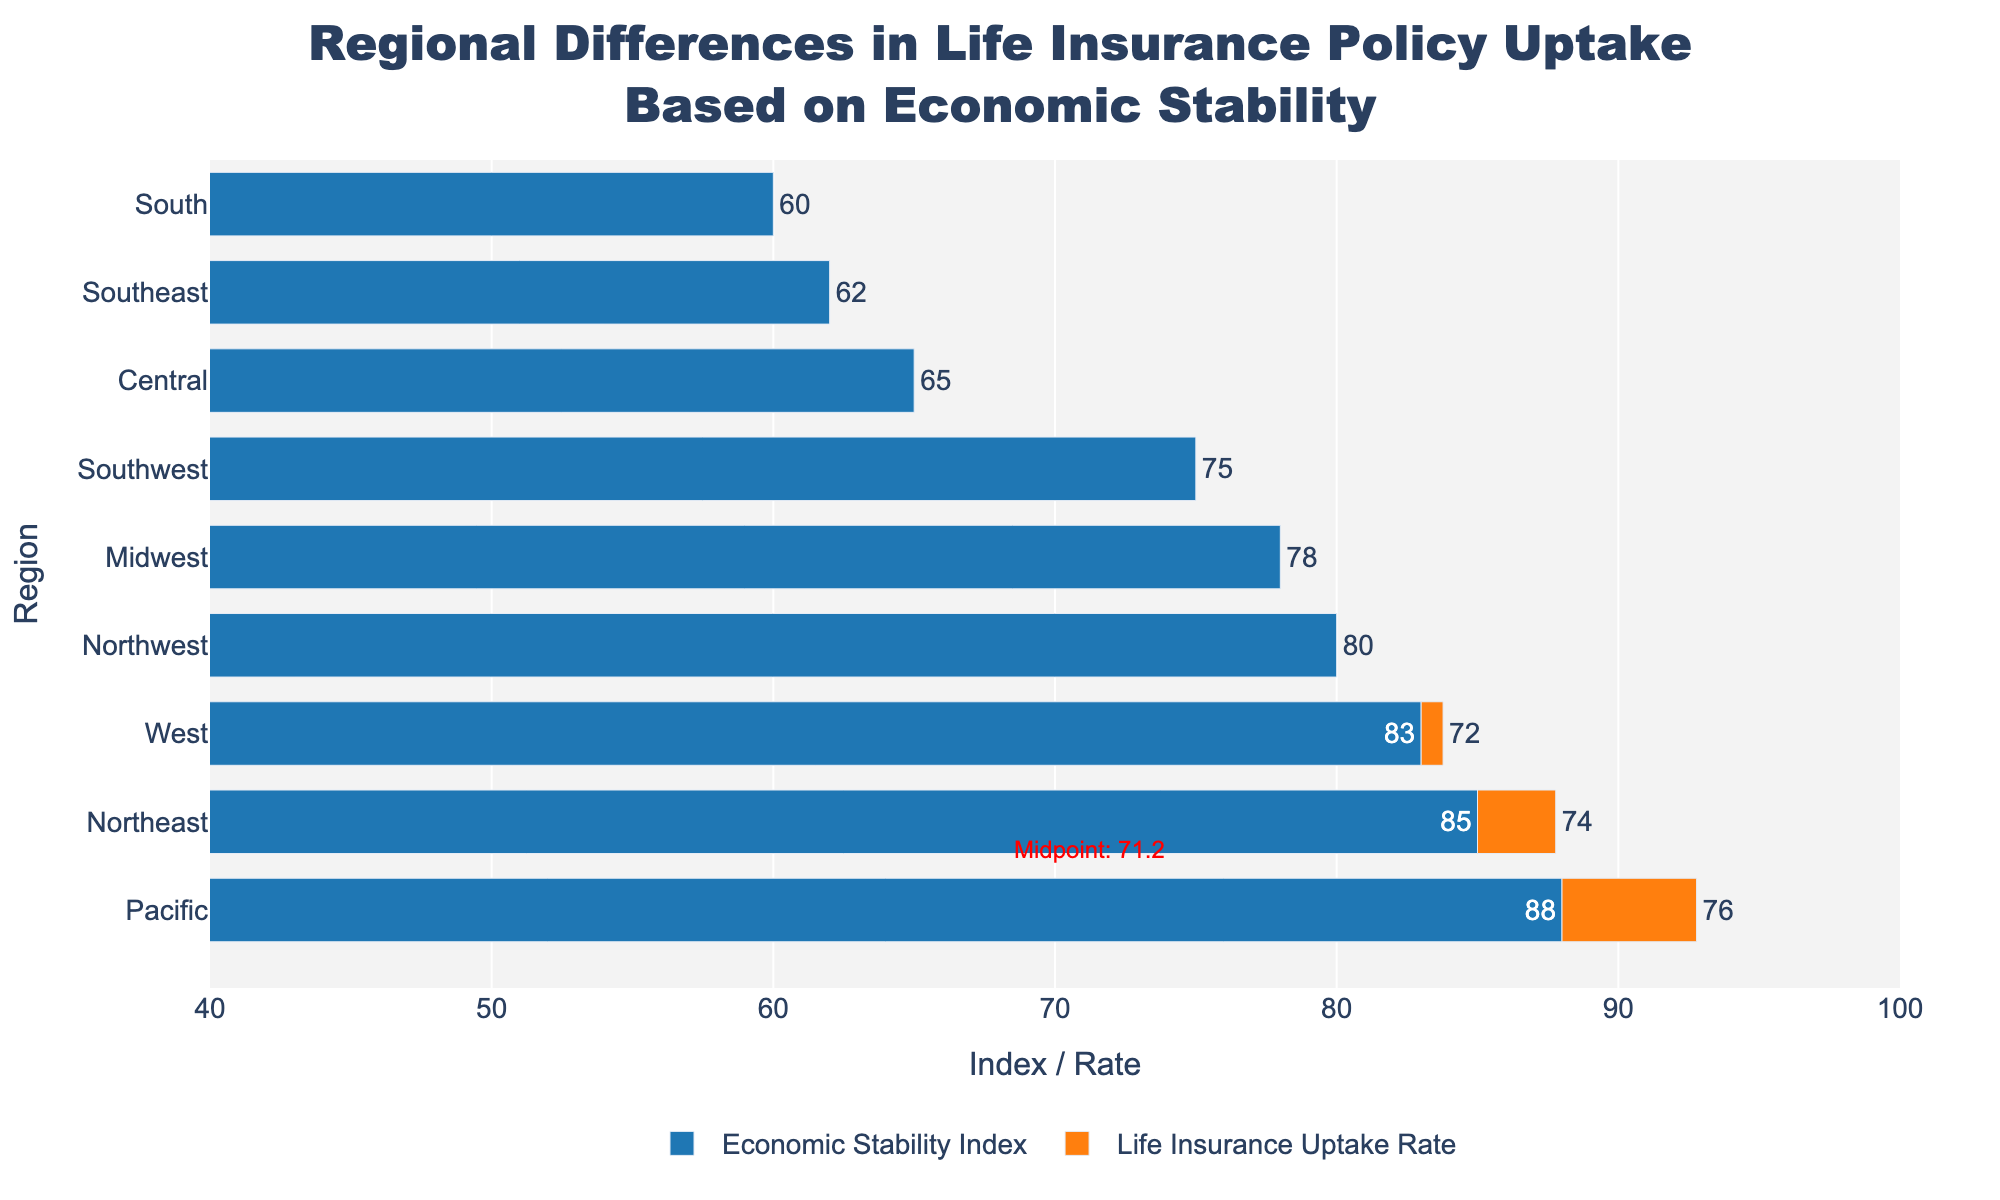Which region has the highest Economic Stability Index? Observing the bars representing the Economic Stability Index, the tallest bar corresponds to the Pacific region with an index of 88.
Answer: Pacific Which region has the lowest Life Insurance Uptake Rate? For the Life Insurance Uptake Rate, the shortest bar represents the South region with a rate of 55.
Answer: South What is the midpoint value used in the diverging bar chart? The midpoint is annotated in red text on the chart at the top alongside the bar for the Northwest region. The value is approximately 72.3.
Answer: 72.3 How does the Life Insurance Uptake Rate for the Midwest compare to its Economic Stability Index? The Economic Stability Index for the Midwest is 78, and the Life Insurance Uptake Rate is 70. Thus, the Life Insurance Uptake Rate is lower than the Economic Stability Index.
Answer: Lower What are the regions where the Life Insurance Uptake Rate exceeds the Economic Stability Index? By comparing the two values for each region, only the Central region has a Life Insurance Uptake Rate (62) that exceeds the Economic Stability Index (65).
Answer: None Which region has the smallest difference between Economic Stability Index and Life Insurance Uptake Rate? Calculating the differences for each region, Central has a difference of 3 (65 - 62), the smallest observed.
Answer: Central What is the average Economic Stability Index of all regions? Summing all the Economic Stability Index values: 85 + 78 + 60 + 83 + 75 + 62 + 80 + 65 + 88 = 676, and dividing by the number of regions (9), the average is 676 / 9 ≈ 75.1.
Answer: 75.1 Which regions have a Life Insurance Uptake Rate greater than the midpoint? Comparing each region’s Life Insurance Uptake Rate to the midpoint (72.3), only the Pacific region (76) exceeds this value.
Answer: Pacific How does the Economic Stability Index of the Southeast compare to the Southwest? The Southeast has an Economic Stability Index of 62, while the Southwest has an index of 75. Thus, the Southeast's index is lower.
Answer: Lower 